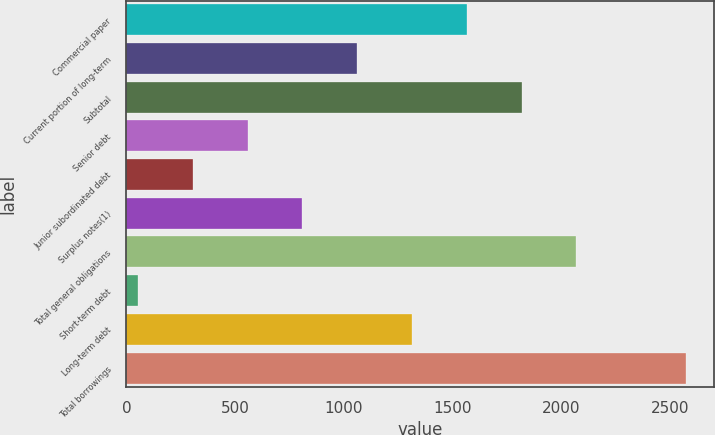Convert chart. <chart><loc_0><loc_0><loc_500><loc_500><bar_chart><fcel>Commercial paper<fcel>Current portion of long-term<fcel>Subtotal<fcel>Senior debt<fcel>Junior subordinated debt<fcel>Surplus notes(1)<fcel>Total general obligations<fcel>Short-term debt<fcel>Long-term debt<fcel>Total borrowings<nl><fcel>1565<fcel>1061<fcel>1817<fcel>557<fcel>305<fcel>809<fcel>2069<fcel>53<fcel>1313<fcel>2573<nl></chart> 